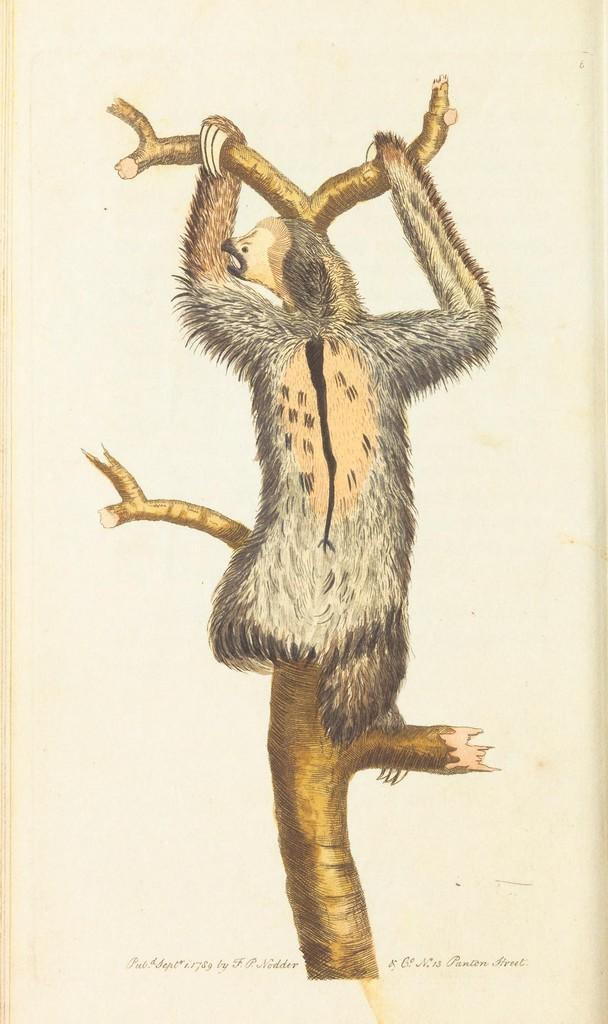In one or two sentences, can you explain what this image depicts? In this image an animal visible on the trunk of tree, at the bottom there is a text, it may be look like a poster. 